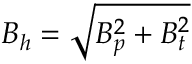<formula> <loc_0><loc_0><loc_500><loc_500>B _ { h } = \sqrt { B _ { p } ^ { 2 } + B _ { t } ^ { 2 } }</formula> 